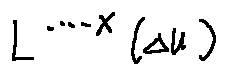<formula> <loc_0><loc_0><loc_500><loc_500>L ^ { \cdots - X } ( \Delta u )</formula> 